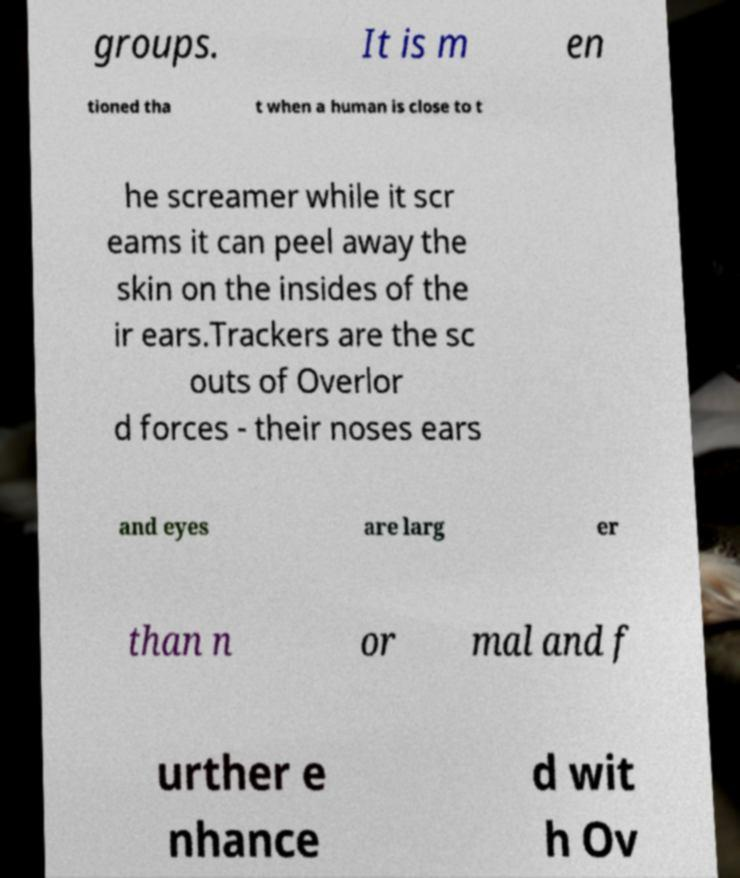Please identify and transcribe the text found in this image. groups. It is m en tioned tha t when a human is close to t he screamer while it scr eams it can peel away the skin on the insides of the ir ears.Trackers are the sc outs of Overlor d forces - their noses ears and eyes are larg er than n or mal and f urther e nhance d wit h Ov 